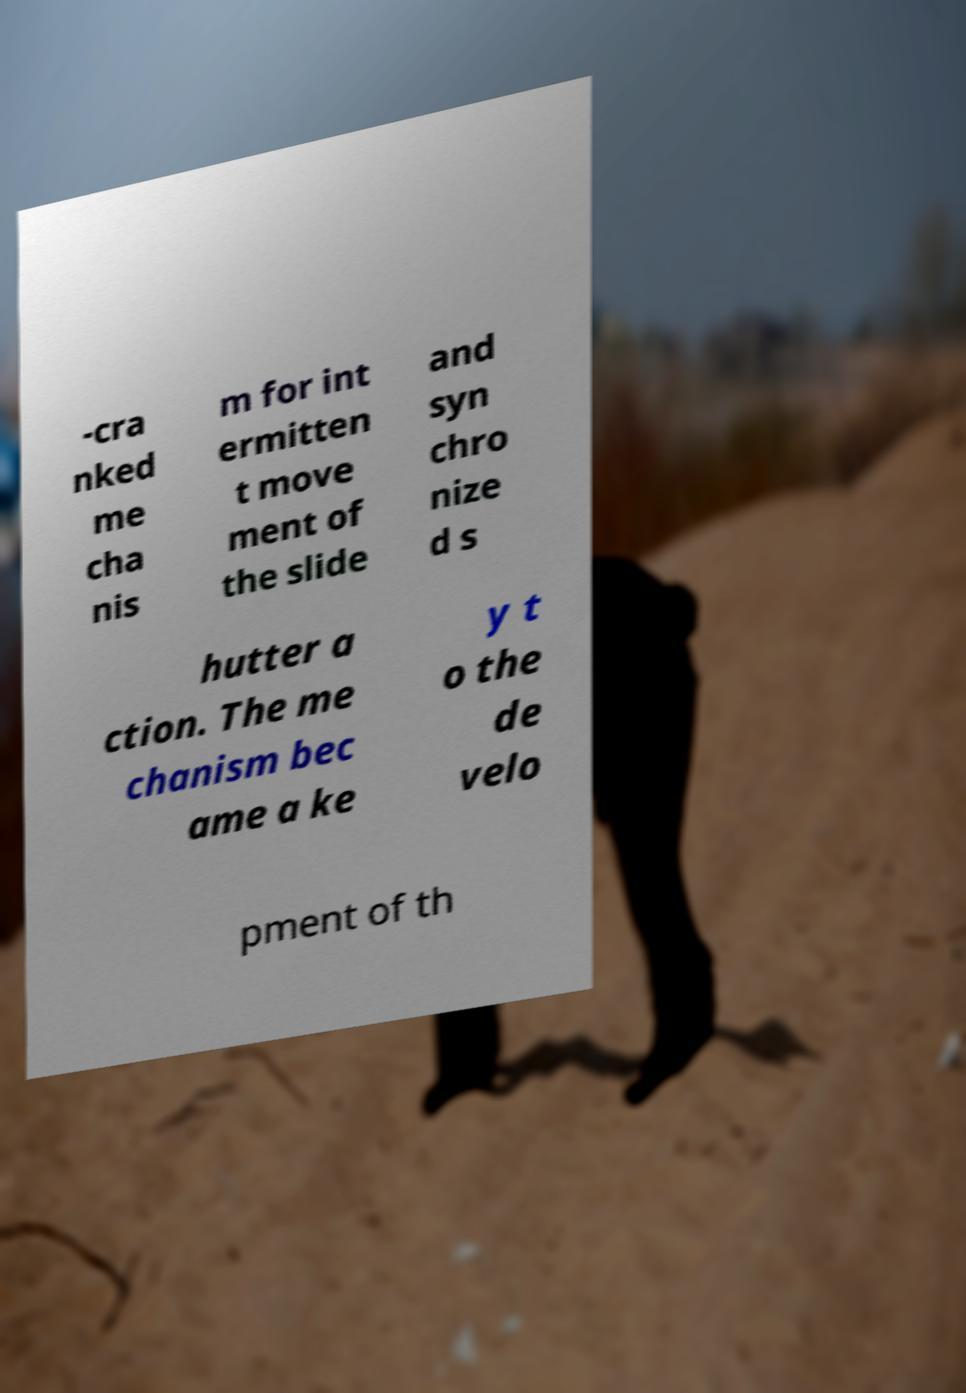Please read and relay the text visible in this image. What does it say? -cra nked me cha nis m for int ermitten t move ment of the slide and syn chro nize d s hutter a ction. The me chanism bec ame a ke y t o the de velo pment of th 